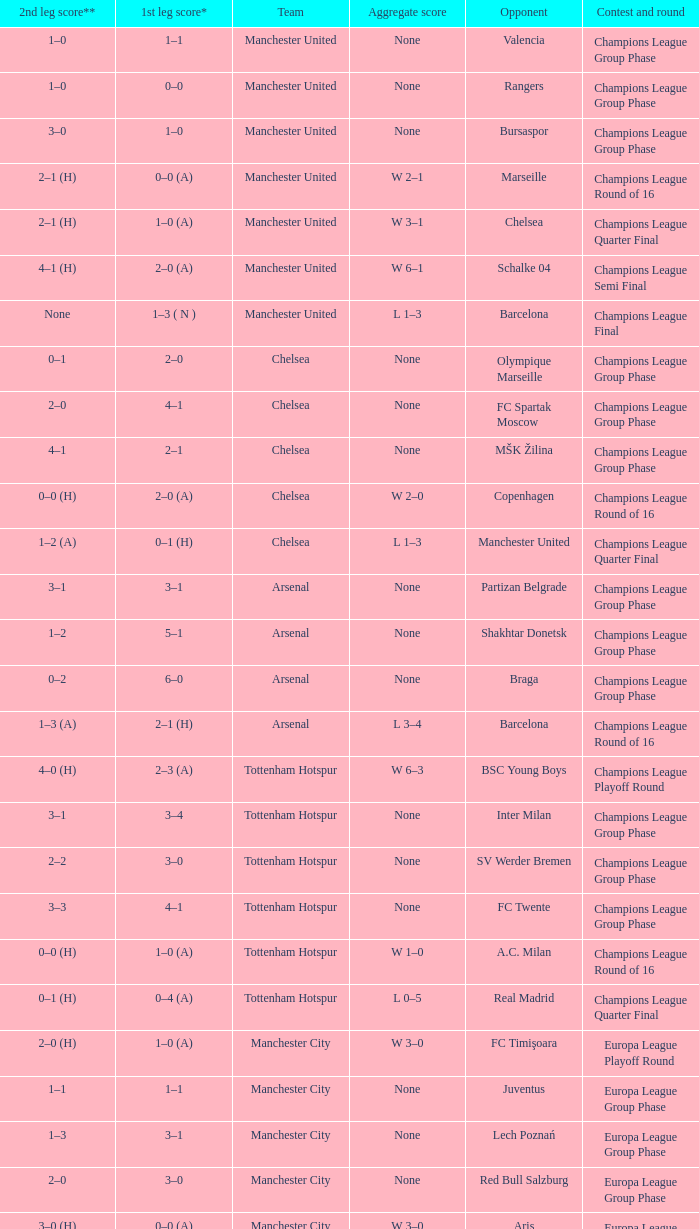What was the score between Marseille and Manchester United on the second leg of the Champions League Round of 16? 2–1 (H). 